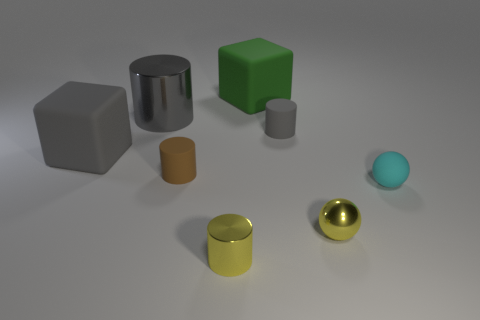The big matte thing that is the same color as the big metallic thing is what shape?
Make the answer very short. Cube. What number of large objects are either gray cylinders or green objects?
Keep it short and to the point. 2. How many small things are both on the right side of the green cube and in front of the cyan matte ball?
Make the answer very short. 1. Is the number of large metallic cylinders greater than the number of small brown metal things?
Offer a terse response. Yes. How many other objects are there of the same shape as the green thing?
Provide a succinct answer. 1. Do the metallic sphere and the small metallic cylinder have the same color?
Offer a terse response. Yes. There is a small object that is on the left side of the green matte object and in front of the cyan ball; what is its material?
Provide a short and direct response. Metal. What size is the green thing?
Offer a very short reply. Large. How many small yellow shiny cylinders are behind the tiny sphere to the left of the ball behind the tiny metal sphere?
Your answer should be compact. 0. The yellow object that is in front of the yellow shiny object that is to the right of the gray matte cylinder is what shape?
Ensure brevity in your answer.  Cylinder. 